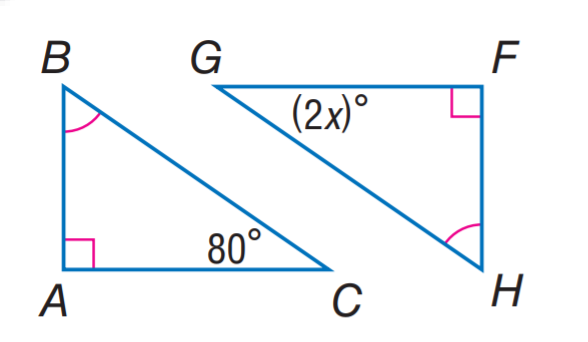Answer the mathemtical geometry problem and directly provide the correct option letter.
Question: Find x.
Choices: A: 30 B: 40 C: 50 D: 80 B 